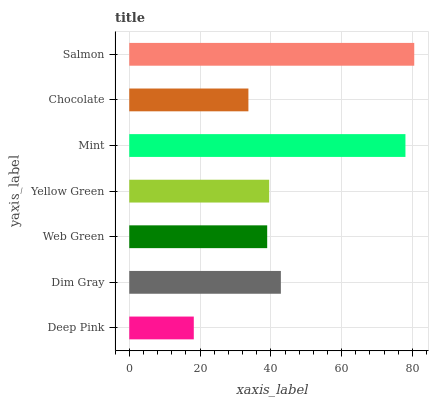Is Deep Pink the minimum?
Answer yes or no. Yes. Is Salmon the maximum?
Answer yes or no. Yes. Is Dim Gray the minimum?
Answer yes or no. No. Is Dim Gray the maximum?
Answer yes or no. No. Is Dim Gray greater than Deep Pink?
Answer yes or no. Yes. Is Deep Pink less than Dim Gray?
Answer yes or no. Yes. Is Deep Pink greater than Dim Gray?
Answer yes or no. No. Is Dim Gray less than Deep Pink?
Answer yes or no. No. Is Yellow Green the high median?
Answer yes or no. Yes. Is Yellow Green the low median?
Answer yes or no. Yes. Is Mint the high median?
Answer yes or no. No. Is Deep Pink the low median?
Answer yes or no. No. 